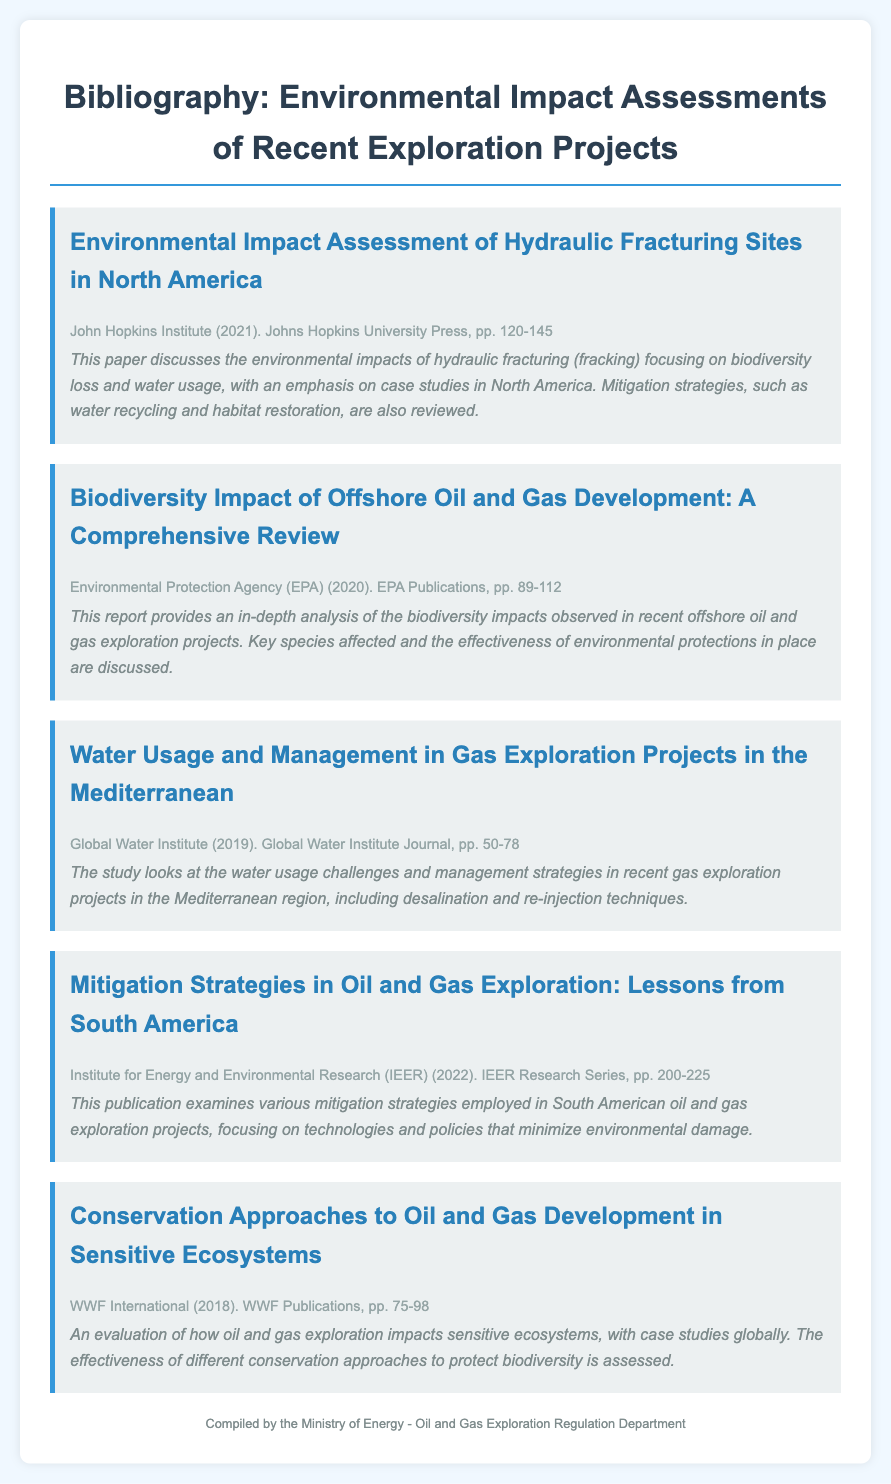what is the title of the first bibliography item? The title is mentioned prominently at the beginning of each item.
Answer: Environmental Impact Assessment of Hydraulic Fracturing Sites in North America who published the second bibliography item? The publisher is listed at the end of the item description.
Answer: Environmental Protection Agency (EPA) what year was the fourth bibliography item published? The year of publication is provided in parentheses next to the publisher's name.
Answer: 2022 which biodiversity impact report focuses on offshore development? The second item's summary indicates its geographical focus.
Answer: Biodiversity Impact of Offshore Oil and Gas Development: A Comprehensive Review what is the focus of the third bibliography item? The summary provides insights into the main topic of the item.
Answer: Water usage and management in gas exploration projects how many pages does the fifth bibliography item cover? The page range is explicitly mentioned at the end of the citation.
Answer: 75-98 what type of study does the last bibliography item evaluate? The title gives insight into the subject of evaluation.
Answer: Conservation Approaches to Oil and Gas Development which publishing series is the third bibliography item part of? The information is found in the publication line of the item.
Answer: Global Water Institute Journal 